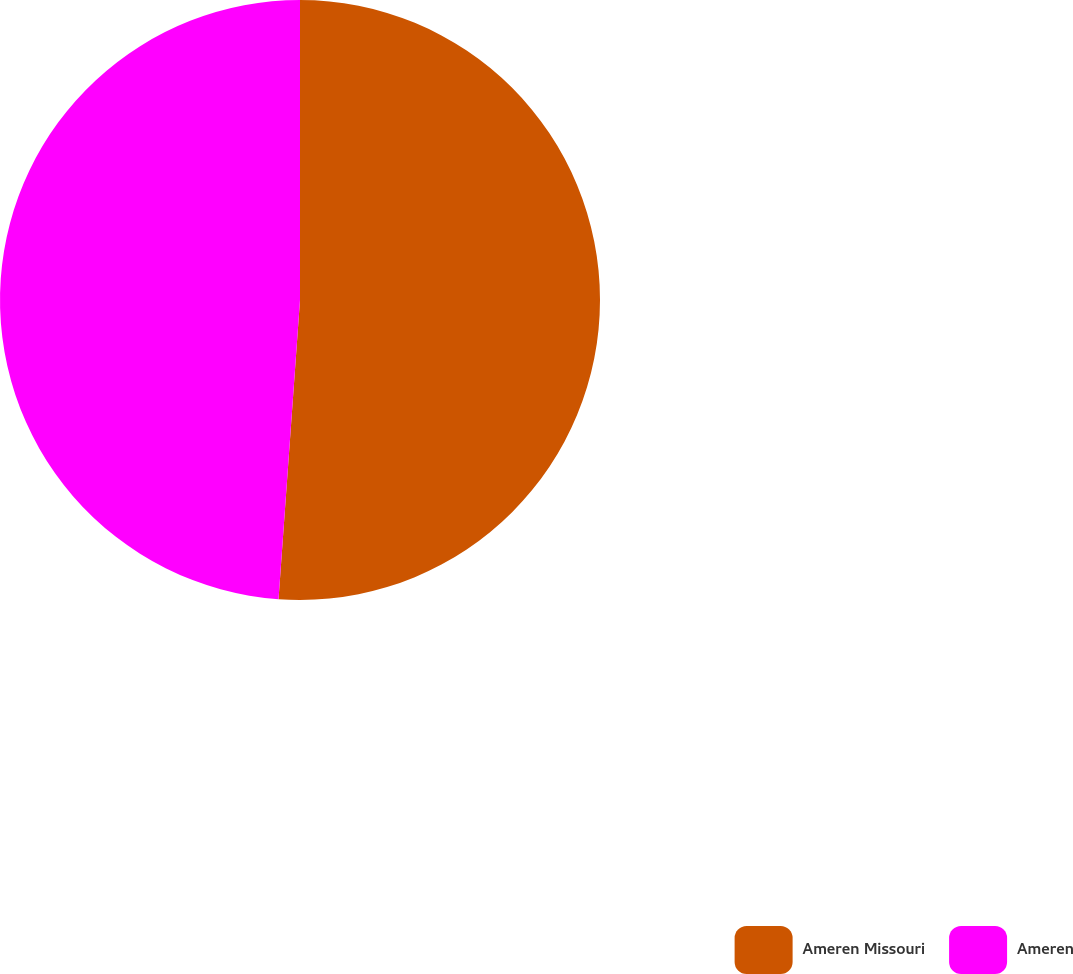<chart> <loc_0><loc_0><loc_500><loc_500><pie_chart><fcel>Ameren Missouri<fcel>Ameren<nl><fcel>51.14%<fcel>48.86%<nl></chart> 